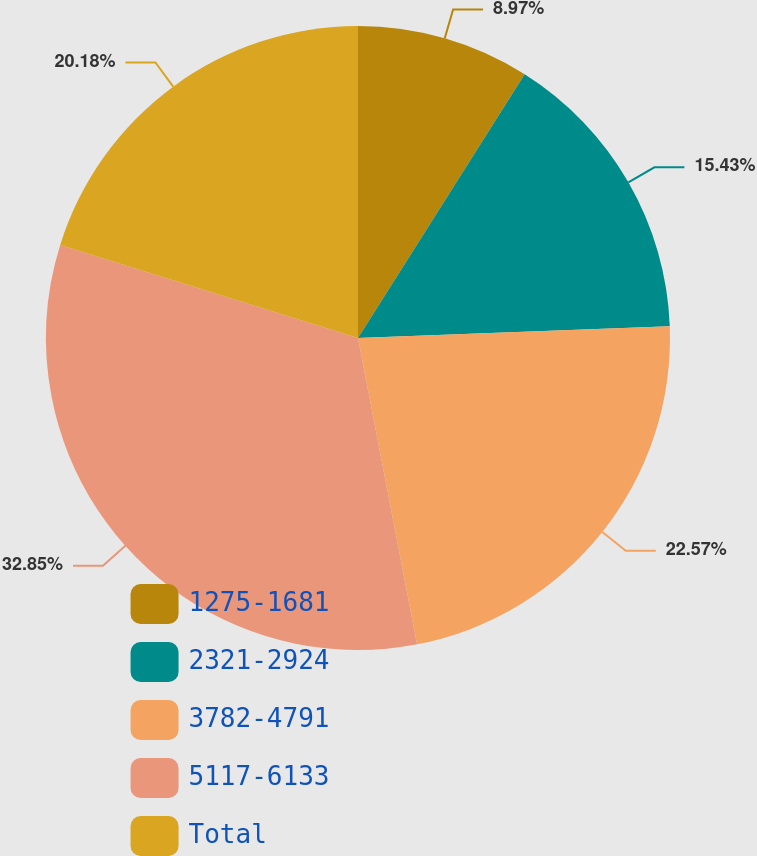Convert chart. <chart><loc_0><loc_0><loc_500><loc_500><pie_chart><fcel>1275-1681<fcel>2321-2924<fcel>3782-4791<fcel>5117-6133<fcel>Total<nl><fcel>8.97%<fcel>15.43%<fcel>22.57%<fcel>32.85%<fcel>20.18%<nl></chart> 